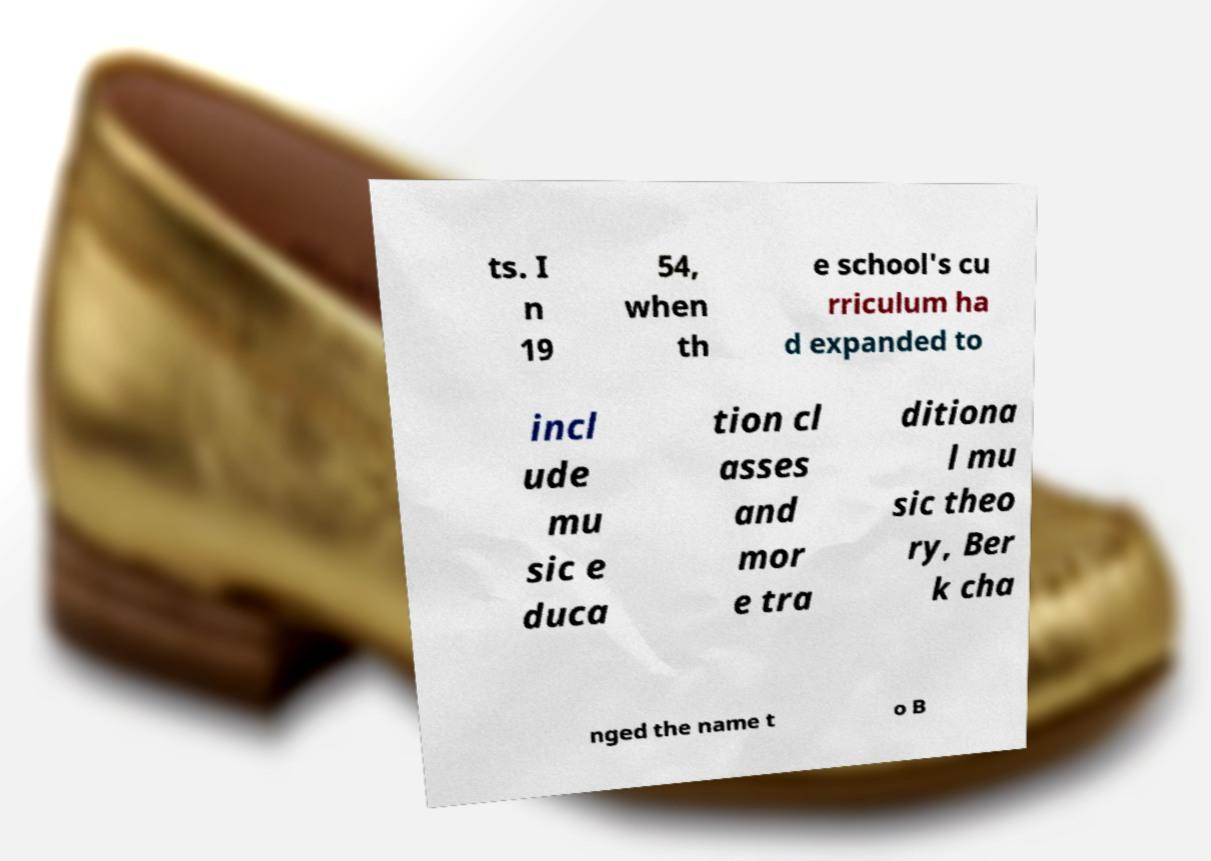Can you accurately transcribe the text from the provided image for me? ts. I n 19 54, when th e school's cu rriculum ha d expanded to incl ude mu sic e duca tion cl asses and mor e tra ditiona l mu sic theo ry, Ber k cha nged the name t o B 